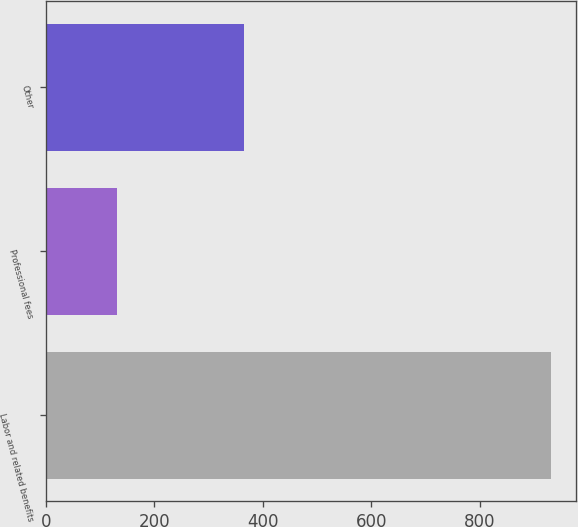Convert chart to OTSL. <chart><loc_0><loc_0><loc_500><loc_500><bar_chart><fcel>Labor and related benefits<fcel>Professional fees<fcel>Other<nl><fcel>931<fcel>131<fcel>365<nl></chart> 